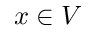Convert formula to latex. <formula><loc_0><loc_0><loc_500><loc_500>x \in V</formula> 